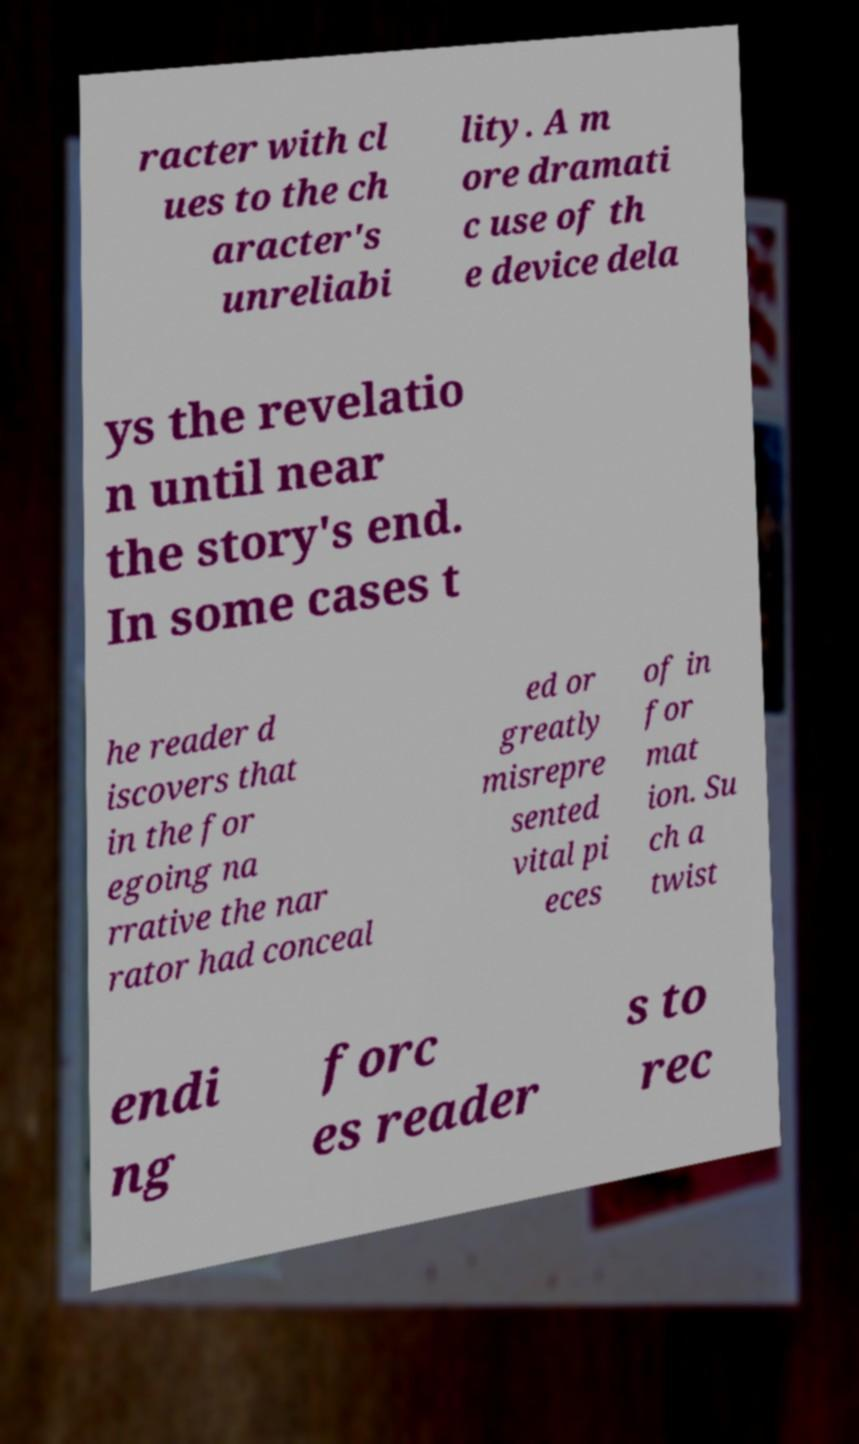Could you extract and type out the text from this image? racter with cl ues to the ch aracter's unreliabi lity. A m ore dramati c use of th e device dela ys the revelatio n until near the story's end. In some cases t he reader d iscovers that in the for egoing na rrative the nar rator had conceal ed or greatly misrepre sented vital pi eces of in for mat ion. Su ch a twist endi ng forc es reader s to rec 